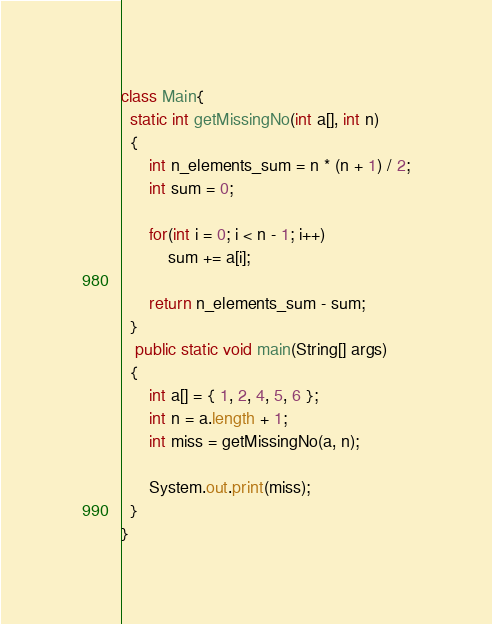Convert code to text. <code><loc_0><loc_0><loc_500><loc_500><_Java_>class Main{
  static int getMissingNo(int a[], int n)
  {
      int n_elements_sum = n * (n + 1) / 2;
      int sum = 0;

      for(int i = 0; i < n - 1; i++)
          sum += a[i];

      return n_elements_sum - sum;
  }
   public static void main(String[] args)
  {
      int a[] = { 1, 2, 4, 5, 6 };
      int n = a.length + 1;
      int miss = getMissingNo(a, n);

      System.out.print(miss);
  }
}
</code> 